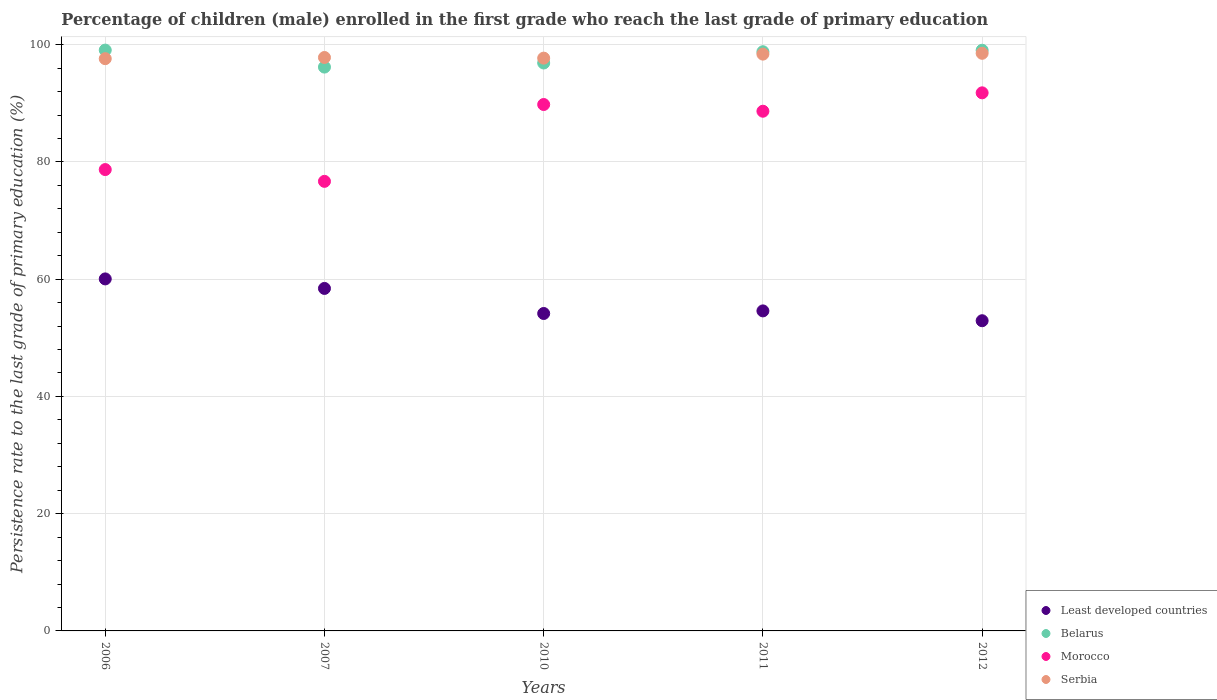What is the persistence rate of children in Serbia in 2011?
Offer a very short reply. 98.39. Across all years, what is the maximum persistence rate of children in Serbia?
Offer a very short reply. 98.53. Across all years, what is the minimum persistence rate of children in Belarus?
Your response must be concise. 96.18. In which year was the persistence rate of children in Belarus maximum?
Your response must be concise. 2006. In which year was the persistence rate of children in Least developed countries minimum?
Your response must be concise. 2012. What is the total persistence rate of children in Morocco in the graph?
Make the answer very short. 425.62. What is the difference between the persistence rate of children in Belarus in 2007 and that in 2011?
Your answer should be very brief. -2.62. What is the difference between the persistence rate of children in Morocco in 2007 and the persistence rate of children in Least developed countries in 2012?
Offer a very short reply. 23.77. What is the average persistence rate of children in Serbia per year?
Give a very brief answer. 98.01. In the year 2007, what is the difference between the persistence rate of children in Belarus and persistence rate of children in Serbia?
Provide a short and direct response. -1.64. What is the ratio of the persistence rate of children in Least developed countries in 2006 to that in 2007?
Your answer should be compact. 1.03. Is the persistence rate of children in Least developed countries in 2006 less than that in 2012?
Keep it short and to the point. No. What is the difference between the highest and the second highest persistence rate of children in Morocco?
Provide a succinct answer. 1.99. What is the difference between the highest and the lowest persistence rate of children in Belarus?
Offer a very short reply. 2.9. Is the sum of the persistence rate of children in Serbia in 2007 and 2010 greater than the maximum persistence rate of children in Least developed countries across all years?
Your response must be concise. Yes. Is it the case that in every year, the sum of the persistence rate of children in Serbia and persistence rate of children in Morocco  is greater than the persistence rate of children in Belarus?
Your answer should be compact. Yes. Does the persistence rate of children in Morocco monotonically increase over the years?
Your response must be concise. No. Is the persistence rate of children in Morocco strictly less than the persistence rate of children in Least developed countries over the years?
Give a very brief answer. No. What is the difference between two consecutive major ticks on the Y-axis?
Your answer should be compact. 20. Does the graph contain any zero values?
Provide a succinct answer. No. Does the graph contain grids?
Offer a terse response. Yes. Where does the legend appear in the graph?
Keep it short and to the point. Bottom right. How many legend labels are there?
Give a very brief answer. 4. How are the legend labels stacked?
Your answer should be very brief. Vertical. What is the title of the graph?
Your answer should be compact. Percentage of children (male) enrolled in the first grade who reach the last grade of primary education. Does "Sri Lanka" appear as one of the legend labels in the graph?
Make the answer very short. No. What is the label or title of the Y-axis?
Keep it short and to the point. Persistence rate to the last grade of primary education (%). What is the Persistence rate to the last grade of primary education (%) in Least developed countries in 2006?
Make the answer very short. 60.05. What is the Persistence rate to the last grade of primary education (%) of Belarus in 2006?
Keep it short and to the point. 99.08. What is the Persistence rate to the last grade of primary education (%) of Morocco in 2006?
Your answer should be very brief. 78.7. What is the Persistence rate to the last grade of primary education (%) in Serbia in 2006?
Your response must be concise. 97.62. What is the Persistence rate to the last grade of primary education (%) of Least developed countries in 2007?
Your answer should be very brief. 58.42. What is the Persistence rate to the last grade of primary education (%) in Belarus in 2007?
Keep it short and to the point. 96.18. What is the Persistence rate to the last grade of primary education (%) in Morocco in 2007?
Your answer should be compact. 76.69. What is the Persistence rate to the last grade of primary education (%) of Serbia in 2007?
Your answer should be compact. 97.82. What is the Persistence rate to the last grade of primary education (%) in Least developed countries in 2010?
Your answer should be compact. 54.15. What is the Persistence rate to the last grade of primary education (%) in Belarus in 2010?
Provide a succinct answer. 96.88. What is the Persistence rate to the last grade of primary education (%) of Morocco in 2010?
Offer a very short reply. 89.8. What is the Persistence rate to the last grade of primary education (%) of Serbia in 2010?
Provide a succinct answer. 97.71. What is the Persistence rate to the last grade of primary education (%) of Least developed countries in 2011?
Offer a very short reply. 54.59. What is the Persistence rate to the last grade of primary education (%) of Belarus in 2011?
Make the answer very short. 98.8. What is the Persistence rate to the last grade of primary education (%) of Morocco in 2011?
Provide a succinct answer. 88.65. What is the Persistence rate to the last grade of primary education (%) in Serbia in 2011?
Keep it short and to the point. 98.39. What is the Persistence rate to the last grade of primary education (%) in Least developed countries in 2012?
Provide a short and direct response. 52.91. What is the Persistence rate to the last grade of primary education (%) in Belarus in 2012?
Ensure brevity in your answer.  99.05. What is the Persistence rate to the last grade of primary education (%) in Morocco in 2012?
Your answer should be very brief. 91.79. What is the Persistence rate to the last grade of primary education (%) of Serbia in 2012?
Provide a short and direct response. 98.53. Across all years, what is the maximum Persistence rate to the last grade of primary education (%) in Least developed countries?
Provide a short and direct response. 60.05. Across all years, what is the maximum Persistence rate to the last grade of primary education (%) of Belarus?
Provide a succinct answer. 99.08. Across all years, what is the maximum Persistence rate to the last grade of primary education (%) in Morocco?
Give a very brief answer. 91.79. Across all years, what is the maximum Persistence rate to the last grade of primary education (%) of Serbia?
Offer a terse response. 98.53. Across all years, what is the minimum Persistence rate to the last grade of primary education (%) in Least developed countries?
Make the answer very short. 52.91. Across all years, what is the minimum Persistence rate to the last grade of primary education (%) in Belarus?
Give a very brief answer. 96.18. Across all years, what is the minimum Persistence rate to the last grade of primary education (%) in Morocco?
Provide a succinct answer. 76.69. Across all years, what is the minimum Persistence rate to the last grade of primary education (%) in Serbia?
Your answer should be compact. 97.62. What is the total Persistence rate to the last grade of primary education (%) of Least developed countries in the graph?
Give a very brief answer. 280.12. What is the total Persistence rate to the last grade of primary education (%) of Belarus in the graph?
Make the answer very short. 489.99. What is the total Persistence rate to the last grade of primary education (%) in Morocco in the graph?
Keep it short and to the point. 425.62. What is the total Persistence rate to the last grade of primary education (%) of Serbia in the graph?
Make the answer very short. 490.07. What is the difference between the Persistence rate to the last grade of primary education (%) in Least developed countries in 2006 and that in 2007?
Provide a short and direct response. 1.62. What is the difference between the Persistence rate to the last grade of primary education (%) in Belarus in 2006 and that in 2007?
Offer a terse response. 2.9. What is the difference between the Persistence rate to the last grade of primary education (%) of Morocco in 2006 and that in 2007?
Make the answer very short. 2.01. What is the difference between the Persistence rate to the last grade of primary education (%) in Serbia in 2006 and that in 2007?
Your answer should be very brief. -0.2. What is the difference between the Persistence rate to the last grade of primary education (%) in Least developed countries in 2006 and that in 2010?
Provide a short and direct response. 5.9. What is the difference between the Persistence rate to the last grade of primary education (%) in Belarus in 2006 and that in 2010?
Your answer should be very brief. 2.2. What is the difference between the Persistence rate to the last grade of primary education (%) in Morocco in 2006 and that in 2010?
Give a very brief answer. -11.1. What is the difference between the Persistence rate to the last grade of primary education (%) of Serbia in 2006 and that in 2010?
Give a very brief answer. -0.09. What is the difference between the Persistence rate to the last grade of primary education (%) in Least developed countries in 2006 and that in 2011?
Your answer should be compact. 5.46. What is the difference between the Persistence rate to the last grade of primary education (%) in Belarus in 2006 and that in 2011?
Keep it short and to the point. 0.28. What is the difference between the Persistence rate to the last grade of primary education (%) of Morocco in 2006 and that in 2011?
Provide a succinct answer. -9.95. What is the difference between the Persistence rate to the last grade of primary education (%) in Serbia in 2006 and that in 2011?
Keep it short and to the point. -0.78. What is the difference between the Persistence rate to the last grade of primary education (%) in Least developed countries in 2006 and that in 2012?
Your answer should be very brief. 7.13. What is the difference between the Persistence rate to the last grade of primary education (%) in Belarus in 2006 and that in 2012?
Your response must be concise. 0.02. What is the difference between the Persistence rate to the last grade of primary education (%) of Morocco in 2006 and that in 2012?
Ensure brevity in your answer.  -13.09. What is the difference between the Persistence rate to the last grade of primary education (%) in Serbia in 2006 and that in 2012?
Ensure brevity in your answer.  -0.92. What is the difference between the Persistence rate to the last grade of primary education (%) of Least developed countries in 2007 and that in 2010?
Give a very brief answer. 4.27. What is the difference between the Persistence rate to the last grade of primary education (%) in Belarus in 2007 and that in 2010?
Offer a very short reply. -0.7. What is the difference between the Persistence rate to the last grade of primary education (%) of Morocco in 2007 and that in 2010?
Provide a succinct answer. -13.11. What is the difference between the Persistence rate to the last grade of primary education (%) of Serbia in 2007 and that in 2010?
Provide a short and direct response. 0.11. What is the difference between the Persistence rate to the last grade of primary education (%) in Least developed countries in 2007 and that in 2011?
Ensure brevity in your answer.  3.83. What is the difference between the Persistence rate to the last grade of primary education (%) in Belarus in 2007 and that in 2011?
Keep it short and to the point. -2.62. What is the difference between the Persistence rate to the last grade of primary education (%) in Morocco in 2007 and that in 2011?
Give a very brief answer. -11.96. What is the difference between the Persistence rate to the last grade of primary education (%) in Serbia in 2007 and that in 2011?
Make the answer very short. -0.58. What is the difference between the Persistence rate to the last grade of primary education (%) of Least developed countries in 2007 and that in 2012?
Your response must be concise. 5.51. What is the difference between the Persistence rate to the last grade of primary education (%) in Belarus in 2007 and that in 2012?
Provide a succinct answer. -2.87. What is the difference between the Persistence rate to the last grade of primary education (%) in Morocco in 2007 and that in 2012?
Your answer should be very brief. -15.1. What is the difference between the Persistence rate to the last grade of primary education (%) of Serbia in 2007 and that in 2012?
Keep it short and to the point. -0.72. What is the difference between the Persistence rate to the last grade of primary education (%) of Least developed countries in 2010 and that in 2011?
Keep it short and to the point. -0.44. What is the difference between the Persistence rate to the last grade of primary education (%) of Belarus in 2010 and that in 2011?
Give a very brief answer. -1.92. What is the difference between the Persistence rate to the last grade of primary education (%) of Morocco in 2010 and that in 2011?
Your answer should be compact. 1.14. What is the difference between the Persistence rate to the last grade of primary education (%) in Serbia in 2010 and that in 2011?
Your response must be concise. -0.69. What is the difference between the Persistence rate to the last grade of primary education (%) of Least developed countries in 2010 and that in 2012?
Ensure brevity in your answer.  1.23. What is the difference between the Persistence rate to the last grade of primary education (%) in Belarus in 2010 and that in 2012?
Make the answer very short. -2.18. What is the difference between the Persistence rate to the last grade of primary education (%) in Morocco in 2010 and that in 2012?
Offer a very short reply. -1.99. What is the difference between the Persistence rate to the last grade of primary education (%) in Serbia in 2010 and that in 2012?
Provide a succinct answer. -0.83. What is the difference between the Persistence rate to the last grade of primary education (%) in Least developed countries in 2011 and that in 2012?
Ensure brevity in your answer.  1.68. What is the difference between the Persistence rate to the last grade of primary education (%) of Belarus in 2011 and that in 2012?
Provide a short and direct response. -0.25. What is the difference between the Persistence rate to the last grade of primary education (%) of Morocco in 2011 and that in 2012?
Give a very brief answer. -3.14. What is the difference between the Persistence rate to the last grade of primary education (%) of Serbia in 2011 and that in 2012?
Provide a short and direct response. -0.14. What is the difference between the Persistence rate to the last grade of primary education (%) of Least developed countries in 2006 and the Persistence rate to the last grade of primary education (%) of Belarus in 2007?
Your answer should be compact. -36.13. What is the difference between the Persistence rate to the last grade of primary education (%) of Least developed countries in 2006 and the Persistence rate to the last grade of primary education (%) of Morocco in 2007?
Your answer should be very brief. -16.64. What is the difference between the Persistence rate to the last grade of primary education (%) in Least developed countries in 2006 and the Persistence rate to the last grade of primary education (%) in Serbia in 2007?
Provide a succinct answer. -37.77. What is the difference between the Persistence rate to the last grade of primary education (%) of Belarus in 2006 and the Persistence rate to the last grade of primary education (%) of Morocco in 2007?
Your answer should be very brief. 22.39. What is the difference between the Persistence rate to the last grade of primary education (%) in Belarus in 2006 and the Persistence rate to the last grade of primary education (%) in Serbia in 2007?
Your response must be concise. 1.26. What is the difference between the Persistence rate to the last grade of primary education (%) of Morocco in 2006 and the Persistence rate to the last grade of primary education (%) of Serbia in 2007?
Your answer should be very brief. -19.12. What is the difference between the Persistence rate to the last grade of primary education (%) of Least developed countries in 2006 and the Persistence rate to the last grade of primary education (%) of Belarus in 2010?
Ensure brevity in your answer.  -36.83. What is the difference between the Persistence rate to the last grade of primary education (%) of Least developed countries in 2006 and the Persistence rate to the last grade of primary education (%) of Morocco in 2010?
Offer a very short reply. -29.75. What is the difference between the Persistence rate to the last grade of primary education (%) in Least developed countries in 2006 and the Persistence rate to the last grade of primary education (%) in Serbia in 2010?
Provide a short and direct response. -37.66. What is the difference between the Persistence rate to the last grade of primary education (%) of Belarus in 2006 and the Persistence rate to the last grade of primary education (%) of Morocco in 2010?
Provide a succinct answer. 9.28. What is the difference between the Persistence rate to the last grade of primary education (%) in Belarus in 2006 and the Persistence rate to the last grade of primary education (%) in Serbia in 2010?
Offer a terse response. 1.37. What is the difference between the Persistence rate to the last grade of primary education (%) of Morocco in 2006 and the Persistence rate to the last grade of primary education (%) of Serbia in 2010?
Give a very brief answer. -19.01. What is the difference between the Persistence rate to the last grade of primary education (%) of Least developed countries in 2006 and the Persistence rate to the last grade of primary education (%) of Belarus in 2011?
Your answer should be compact. -38.75. What is the difference between the Persistence rate to the last grade of primary education (%) of Least developed countries in 2006 and the Persistence rate to the last grade of primary education (%) of Morocco in 2011?
Ensure brevity in your answer.  -28.61. What is the difference between the Persistence rate to the last grade of primary education (%) of Least developed countries in 2006 and the Persistence rate to the last grade of primary education (%) of Serbia in 2011?
Give a very brief answer. -38.35. What is the difference between the Persistence rate to the last grade of primary education (%) in Belarus in 2006 and the Persistence rate to the last grade of primary education (%) in Morocco in 2011?
Offer a very short reply. 10.43. What is the difference between the Persistence rate to the last grade of primary education (%) in Belarus in 2006 and the Persistence rate to the last grade of primary education (%) in Serbia in 2011?
Your answer should be compact. 0.68. What is the difference between the Persistence rate to the last grade of primary education (%) of Morocco in 2006 and the Persistence rate to the last grade of primary education (%) of Serbia in 2011?
Provide a succinct answer. -19.69. What is the difference between the Persistence rate to the last grade of primary education (%) of Least developed countries in 2006 and the Persistence rate to the last grade of primary education (%) of Belarus in 2012?
Your answer should be compact. -39.01. What is the difference between the Persistence rate to the last grade of primary education (%) of Least developed countries in 2006 and the Persistence rate to the last grade of primary education (%) of Morocco in 2012?
Your response must be concise. -31.74. What is the difference between the Persistence rate to the last grade of primary education (%) in Least developed countries in 2006 and the Persistence rate to the last grade of primary education (%) in Serbia in 2012?
Ensure brevity in your answer.  -38.49. What is the difference between the Persistence rate to the last grade of primary education (%) of Belarus in 2006 and the Persistence rate to the last grade of primary education (%) of Morocco in 2012?
Give a very brief answer. 7.29. What is the difference between the Persistence rate to the last grade of primary education (%) in Belarus in 2006 and the Persistence rate to the last grade of primary education (%) in Serbia in 2012?
Offer a very short reply. 0.54. What is the difference between the Persistence rate to the last grade of primary education (%) in Morocco in 2006 and the Persistence rate to the last grade of primary education (%) in Serbia in 2012?
Keep it short and to the point. -19.83. What is the difference between the Persistence rate to the last grade of primary education (%) of Least developed countries in 2007 and the Persistence rate to the last grade of primary education (%) of Belarus in 2010?
Keep it short and to the point. -38.45. What is the difference between the Persistence rate to the last grade of primary education (%) in Least developed countries in 2007 and the Persistence rate to the last grade of primary education (%) in Morocco in 2010?
Offer a terse response. -31.37. What is the difference between the Persistence rate to the last grade of primary education (%) of Least developed countries in 2007 and the Persistence rate to the last grade of primary education (%) of Serbia in 2010?
Your response must be concise. -39.28. What is the difference between the Persistence rate to the last grade of primary education (%) in Belarus in 2007 and the Persistence rate to the last grade of primary education (%) in Morocco in 2010?
Make the answer very short. 6.38. What is the difference between the Persistence rate to the last grade of primary education (%) of Belarus in 2007 and the Persistence rate to the last grade of primary education (%) of Serbia in 2010?
Offer a terse response. -1.53. What is the difference between the Persistence rate to the last grade of primary education (%) of Morocco in 2007 and the Persistence rate to the last grade of primary education (%) of Serbia in 2010?
Give a very brief answer. -21.02. What is the difference between the Persistence rate to the last grade of primary education (%) of Least developed countries in 2007 and the Persistence rate to the last grade of primary education (%) of Belarus in 2011?
Your response must be concise. -40.38. What is the difference between the Persistence rate to the last grade of primary education (%) in Least developed countries in 2007 and the Persistence rate to the last grade of primary education (%) in Morocco in 2011?
Give a very brief answer. -30.23. What is the difference between the Persistence rate to the last grade of primary education (%) in Least developed countries in 2007 and the Persistence rate to the last grade of primary education (%) in Serbia in 2011?
Your answer should be compact. -39.97. What is the difference between the Persistence rate to the last grade of primary education (%) in Belarus in 2007 and the Persistence rate to the last grade of primary education (%) in Morocco in 2011?
Provide a short and direct response. 7.53. What is the difference between the Persistence rate to the last grade of primary education (%) in Belarus in 2007 and the Persistence rate to the last grade of primary education (%) in Serbia in 2011?
Make the answer very short. -2.21. What is the difference between the Persistence rate to the last grade of primary education (%) of Morocco in 2007 and the Persistence rate to the last grade of primary education (%) of Serbia in 2011?
Provide a short and direct response. -21.7. What is the difference between the Persistence rate to the last grade of primary education (%) of Least developed countries in 2007 and the Persistence rate to the last grade of primary education (%) of Belarus in 2012?
Give a very brief answer. -40.63. What is the difference between the Persistence rate to the last grade of primary education (%) of Least developed countries in 2007 and the Persistence rate to the last grade of primary education (%) of Morocco in 2012?
Make the answer very short. -33.37. What is the difference between the Persistence rate to the last grade of primary education (%) in Least developed countries in 2007 and the Persistence rate to the last grade of primary education (%) in Serbia in 2012?
Provide a short and direct response. -40.11. What is the difference between the Persistence rate to the last grade of primary education (%) of Belarus in 2007 and the Persistence rate to the last grade of primary education (%) of Morocco in 2012?
Keep it short and to the point. 4.39. What is the difference between the Persistence rate to the last grade of primary education (%) in Belarus in 2007 and the Persistence rate to the last grade of primary education (%) in Serbia in 2012?
Make the answer very short. -2.35. What is the difference between the Persistence rate to the last grade of primary education (%) in Morocco in 2007 and the Persistence rate to the last grade of primary education (%) in Serbia in 2012?
Keep it short and to the point. -21.84. What is the difference between the Persistence rate to the last grade of primary education (%) in Least developed countries in 2010 and the Persistence rate to the last grade of primary education (%) in Belarus in 2011?
Your answer should be very brief. -44.65. What is the difference between the Persistence rate to the last grade of primary education (%) in Least developed countries in 2010 and the Persistence rate to the last grade of primary education (%) in Morocco in 2011?
Provide a succinct answer. -34.5. What is the difference between the Persistence rate to the last grade of primary education (%) of Least developed countries in 2010 and the Persistence rate to the last grade of primary education (%) of Serbia in 2011?
Make the answer very short. -44.24. What is the difference between the Persistence rate to the last grade of primary education (%) in Belarus in 2010 and the Persistence rate to the last grade of primary education (%) in Morocco in 2011?
Give a very brief answer. 8.23. What is the difference between the Persistence rate to the last grade of primary education (%) in Belarus in 2010 and the Persistence rate to the last grade of primary education (%) in Serbia in 2011?
Keep it short and to the point. -1.52. What is the difference between the Persistence rate to the last grade of primary education (%) in Morocco in 2010 and the Persistence rate to the last grade of primary education (%) in Serbia in 2011?
Provide a short and direct response. -8.6. What is the difference between the Persistence rate to the last grade of primary education (%) of Least developed countries in 2010 and the Persistence rate to the last grade of primary education (%) of Belarus in 2012?
Give a very brief answer. -44.9. What is the difference between the Persistence rate to the last grade of primary education (%) in Least developed countries in 2010 and the Persistence rate to the last grade of primary education (%) in Morocco in 2012?
Keep it short and to the point. -37.64. What is the difference between the Persistence rate to the last grade of primary education (%) of Least developed countries in 2010 and the Persistence rate to the last grade of primary education (%) of Serbia in 2012?
Provide a succinct answer. -44.38. What is the difference between the Persistence rate to the last grade of primary education (%) of Belarus in 2010 and the Persistence rate to the last grade of primary education (%) of Morocco in 2012?
Your answer should be compact. 5.09. What is the difference between the Persistence rate to the last grade of primary education (%) of Belarus in 2010 and the Persistence rate to the last grade of primary education (%) of Serbia in 2012?
Offer a terse response. -1.65. What is the difference between the Persistence rate to the last grade of primary education (%) in Morocco in 2010 and the Persistence rate to the last grade of primary education (%) in Serbia in 2012?
Provide a succinct answer. -8.74. What is the difference between the Persistence rate to the last grade of primary education (%) in Least developed countries in 2011 and the Persistence rate to the last grade of primary education (%) in Belarus in 2012?
Your response must be concise. -44.46. What is the difference between the Persistence rate to the last grade of primary education (%) in Least developed countries in 2011 and the Persistence rate to the last grade of primary education (%) in Morocco in 2012?
Ensure brevity in your answer.  -37.2. What is the difference between the Persistence rate to the last grade of primary education (%) of Least developed countries in 2011 and the Persistence rate to the last grade of primary education (%) of Serbia in 2012?
Offer a very short reply. -43.94. What is the difference between the Persistence rate to the last grade of primary education (%) in Belarus in 2011 and the Persistence rate to the last grade of primary education (%) in Morocco in 2012?
Keep it short and to the point. 7.01. What is the difference between the Persistence rate to the last grade of primary education (%) in Belarus in 2011 and the Persistence rate to the last grade of primary education (%) in Serbia in 2012?
Keep it short and to the point. 0.27. What is the difference between the Persistence rate to the last grade of primary education (%) in Morocco in 2011 and the Persistence rate to the last grade of primary education (%) in Serbia in 2012?
Make the answer very short. -9.88. What is the average Persistence rate to the last grade of primary education (%) in Least developed countries per year?
Your answer should be very brief. 56.02. What is the average Persistence rate to the last grade of primary education (%) of Belarus per year?
Offer a terse response. 98. What is the average Persistence rate to the last grade of primary education (%) of Morocco per year?
Your answer should be compact. 85.12. What is the average Persistence rate to the last grade of primary education (%) in Serbia per year?
Offer a terse response. 98.01. In the year 2006, what is the difference between the Persistence rate to the last grade of primary education (%) of Least developed countries and Persistence rate to the last grade of primary education (%) of Belarus?
Your response must be concise. -39.03. In the year 2006, what is the difference between the Persistence rate to the last grade of primary education (%) of Least developed countries and Persistence rate to the last grade of primary education (%) of Morocco?
Provide a succinct answer. -18.65. In the year 2006, what is the difference between the Persistence rate to the last grade of primary education (%) of Least developed countries and Persistence rate to the last grade of primary education (%) of Serbia?
Your response must be concise. -37.57. In the year 2006, what is the difference between the Persistence rate to the last grade of primary education (%) in Belarus and Persistence rate to the last grade of primary education (%) in Morocco?
Provide a succinct answer. 20.38. In the year 2006, what is the difference between the Persistence rate to the last grade of primary education (%) in Belarus and Persistence rate to the last grade of primary education (%) in Serbia?
Your answer should be very brief. 1.46. In the year 2006, what is the difference between the Persistence rate to the last grade of primary education (%) in Morocco and Persistence rate to the last grade of primary education (%) in Serbia?
Provide a short and direct response. -18.92. In the year 2007, what is the difference between the Persistence rate to the last grade of primary education (%) of Least developed countries and Persistence rate to the last grade of primary education (%) of Belarus?
Keep it short and to the point. -37.76. In the year 2007, what is the difference between the Persistence rate to the last grade of primary education (%) of Least developed countries and Persistence rate to the last grade of primary education (%) of Morocco?
Keep it short and to the point. -18.27. In the year 2007, what is the difference between the Persistence rate to the last grade of primary education (%) in Least developed countries and Persistence rate to the last grade of primary education (%) in Serbia?
Offer a very short reply. -39.39. In the year 2007, what is the difference between the Persistence rate to the last grade of primary education (%) of Belarus and Persistence rate to the last grade of primary education (%) of Morocco?
Ensure brevity in your answer.  19.49. In the year 2007, what is the difference between the Persistence rate to the last grade of primary education (%) of Belarus and Persistence rate to the last grade of primary education (%) of Serbia?
Give a very brief answer. -1.64. In the year 2007, what is the difference between the Persistence rate to the last grade of primary education (%) of Morocco and Persistence rate to the last grade of primary education (%) of Serbia?
Provide a short and direct response. -21.13. In the year 2010, what is the difference between the Persistence rate to the last grade of primary education (%) of Least developed countries and Persistence rate to the last grade of primary education (%) of Belarus?
Provide a succinct answer. -42.73. In the year 2010, what is the difference between the Persistence rate to the last grade of primary education (%) of Least developed countries and Persistence rate to the last grade of primary education (%) of Morocco?
Your response must be concise. -35.65. In the year 2010, what is the difference between the Persistence rate to the last grade of primary education (%) in Least developed countries and Persistence rate to the last grade of primary education (%) in Serbia?
Ensure brevity in your answer.  -43.56. In the year 2010, what is the difference between the Persistence rate to the last grade of primary education (%) of Belarus and Persistence rate to the last grade of primary education (%) of Morocco?
Keep it short and to the point. 7.08. In the year 2010, what is the difference between the Persistence rate to the last grade of primary education (%) of Belarus and Persistence rate to the last grade of primary education (%) of Serbia?
Make the answer very short. -0.83. In the year 2010, what is the difference between the Persistence rate to the last grade of primary education (%) in Morocco and Persistence rate to the last grade of primary education (%) in Serbia?
Your answer should be compact. -7.91. In the year 2011, what is the difference between the Persistence rate to the last grade of primary education (%) of Least developed countries and Persistence rate to the last grade of primary education (%) of Belarus?
Your response must be concise. -44.21. In the year 2011, what is the difference between the Persistence rate to the last grade of primary education (%) in Least developed countries and Persistence rate to the last grade of primary education (%) in Morocco?
Keep it short and to the point. -34.06. In the year 2011, what is the difference between the Persistence rate to the last grade of primary education (%) in Least developed countries and Persistence rate to the last grade of primary education (%) in Serbia?
Your response must be concise. -43.8. In the year 2011, what is the difference between the Persistence rate to the last grade of primary education (%) in Belarus and Persistence rate to the last grade of primary education (%) in Morocco?
Provide a succinct answer. 10.15. In the year 2011, what is the difference between the Persistence rate to the last grade of primary education (%) of Belarus and Persistence rate to the last grade of primary education (%) of Serbia?
Keep it short and to the point. 0.41. In the year 2011, what is the difference between the Persistence rate to the last grade of primary education (%) of Morocco and Persistence rate to the last grade of primary education (%) of Serbia?
Make the answer very short. -9.74. In the year 2012, what is the difference between the Persistence rate to the last grade of primary education (%) in Least developed countries and Persistence rate to the last grade of primary education (%) in Belarus?
Your answer should be very brief. -46.14. In the year 2012, what is the difference between the Persistence rate to the last grade of primary education (%) in Least developed countries and Persistence rate to the last grade of primary education (%) in Morocco?
Your answer should be compact. -38.87. In the year 2012, what is the difference between the Persistence rate to the last grade of primary education (%) of Least developed countries and Persistence rate to the last grade of primary education (%) of Serbia?
Ensure brevity in your answer.  -45.62. In the year 2012, what is the difference between the Persistence rate to the last grade of primary education (%) of Belarus and Persistence rate to the last grade of primary education (%) of Morocco?
Ensure brevity in your answer.  7.26. In the year 2012, what is the difference between the Persistence rate to the last grade of primary education (%) in Belarus and Persistence rate to the last grade of primary education (%) in Serbia?
Provide a short and direct response. 0.52. In the year 2012, what is the difference between the Persistence rate to the last grade of primary education (%) of Morocco and Persistence rate to the last grade of primary education (%) of Serbia?
Provide a succinct answer. -6.74. What is the ratio of the Persistence rate to the last grade of primary education (%) of Least developed countries in 2006 to that in 2007?
Your answer should be compact. 1.03. What is the ratio of the Persistence rate to the last grade of primary education (%) of Belarus in 2006 to that in 2007?
Your answer should be very brief. 1.03. What is the ratio of the Persistence rate to the last grade of primary education (%) of Morocco in 2006 to that in 2007?
Offer a very short reply. 1.03. What is the ratio of the Persistence rate to the last grade of primary education (%) of Serbia in 2006 to that in 2007?
Make the answer very short. 1. What is the ratio of the Persistence rate to the last grade of primary education (%) of Least developed countries in 2006 to that in 2010?
Your answer should be compact. 1.11. What is the ratio of the Persistence rate to the last grade of primary education (%) of Belarus in 2006 to that in 2010?
Ensure brevity in your answer.  1.02. What is the ratio of the Persistence rate to the last grade of primary education (%) in Morocco in 2006 to that in 2010?
Provide a short and direct response. 0.88. What is the ratio of the Persistence rate to the last grade of primary education (%) of Least developed countries in 2006 to that in 2011?
Make the answer very short. 1.1. What is the ratio of the Persistence rate to the last grade of primary education (%) of Morocco in 2006 to that in 2011?
Make the answer very short. 0.89. What is the ratio of the Persistence rate to the last grade of primary education (%) of Serbia in 2006 to that in 2011?
Your answer should be very brief. 0.99. What is the ratio of the Persistence rate to the last grade of primary education (%) of Least developed countries in 2006 to that in 2012?
Offer a very short reply. 1.13. What is the ratio of the Persistence rate to the last grade of primary education (%) in Morocco in 2006 to that in 2012?
Offer a terse response. 0.86. What is the ratio of the Persistence rate to the last grade of primary education (%) in Least developed countries in 2007 to that in 2010?
Your answer should be very brief. 1.08. What is the ratio of the Persistence rate to the last grade of primary education (%) of Belarus in 2007 to that in 2010?
Offer a terse response. 0.99. What is the ratio of the Persistence rate to the last grade of primary education (%) in Morocco in 2007 to that in 2010?
Ensure brevity in your answer.  0.85. What is the ratio of the Persistence rate to the last grade of primary education (%) in Serbia in 2007 to that in 2010?
Ensure brevity in your answer.  1. What is the ratio of the Persistence rate to the last grade of primary education (%) in Least developed countries in 2007 to that in 2011?
Your answer should be very brief. 1.07. What is the ratio of the Persistence rate to the last grade of primary education (%) in Belarus in 2007 to that in 2011?
Your answer should be compact. 0.97. What is the ratio of the Persistence rate to the last grade of primary education (%) of Morocco in 2007 to that in 2011?
Provide a succinct answer. 0.87. What is the ratio of the Persistence rate to the last grade of primary education (%) of Serbia in 2007 to that in 2011?
Your answer should be compact. 0.99. What is the ratio of the Persistence rate to the last grade of primary education (%) of Least developed countries in 2007 to that in 2012?
Offer a terse response. 1.1. What is the ratio of the Persistence rate to the last grade of primary education (%) of Morocco in 2007 to that in 2012?
Ensure brevity in your answer.  0.84. What is the ratio of the Persistence rate to the last grade of primary education (%) in Serbia in 2007 to that in 2012?
Your answer should be compact. 0.99. What is the ratio of the Persistence rate to the last grade of primary education (%) of Belarus in 2010 to that in 2011?
Provide a succinct answer. 0.98. What is the ratio of the Persistence rate to the last grade of primary education (%) in Morocco in 2010 to that in 2011?
Provide a succinct answer. 1.01. What is the ratio of the Persistence rate to the last grade of primary education (%) of Serbia in 2010 to that in 2011?
Give a very brief answer. 0.99. What is the ratio of the Persistence rate to the last grade of primary education (%) in Least developed countries in 2010 to that in 2012?
Offer a very short reply. 1.02. What is the ratio of the Persistence rate to the last grade of primary education (%) of Morocco in 2010 to that in 2012?
Your answer should be compact. 0.98. What is the ratio of the Persistence rate to the last grade of primary education (%) of Least developed countries in 2011 to that in 2012?
Provide a short and direct response. 1.03. What is the ratio of the Persistence rate to the last grade of primary education (%) in Morocco in 2011 to that in 2012?
Provide a succinct answer. 0.97. What is the ratio of the Persistence rate to the last grade of primary education (%) of Serbia in 2011 to that in 2012?
Offer a very short reply. 1. What is the difference between the highest and the second highest Persistence rate to the last grade of primary education (%) of Least developed countries?
Ensure brevity in your answer.  1.62. What is the difference between the highest and the second highest Persistence rate to the last grade of primary education (%) in Belarus?
Your answer should be very brief. 0.02. What is the difference between the highest and the second highest Persistence rate to the last grade of primary education (%) in Morocco?
Your answer should be very brief. 1.99. What is the difference between the highest and the second highest Persistence rate to the last grade of primary education (%) of Serbia?
Keep it short and to the point. 0.14. What is the difference between the highest and the lowest Persistence rate to the last grade of primary education (%) of Least developed countries?
Provide a short and direct response. 7.13. What is the difference between the highest and the lowest Persistence rate to the last grade of primary education (%) in Belarus?
Your response must be concise. 2.9. What is the difference between the highest and the lowest Persistence rate to the last grade of primary education (%) of Morocco?
Provide a short and direct response. 15.1. What is the difference between the highest and the lowest Persistence rate to the last grade of primary education (%) of Serbia?
Your answer should be compact. 0.92. 